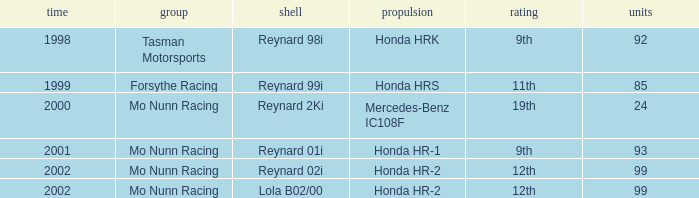What is the rank of the reynard 2ki chassis before 2002? 19th. 